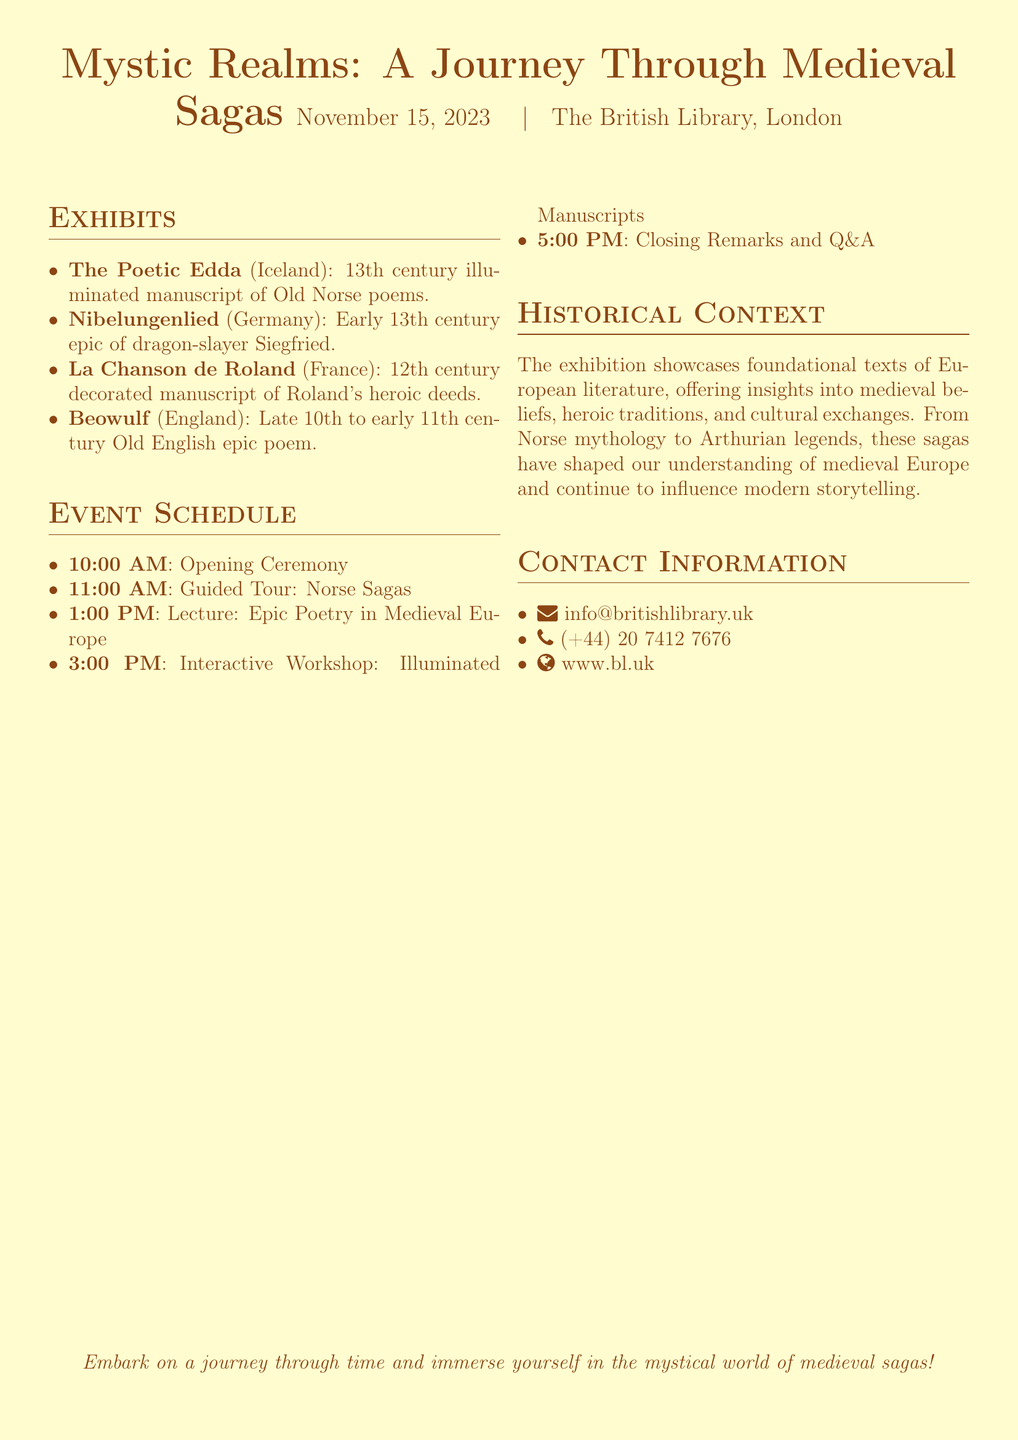What is the title of the exhibition? The title of the exhibition is prominently stated at the beginning of the document.
Answer: Mystic Realms: A Journey Through Medieval Sagas When does the exhibition take place? The date of the exhibition is mentioned near the title.
Answer: November 15, 2023 What is the first event on the schedule? The opening event is listed first in the event schedule section.
Answer: Opening Ceremony How many exhibits are mentioned in the document? The number of exhibits can be counted in the list provided under the exhibits section.
Answer: Four What is the historical context of the exhibition? The historical context outlines the significance of the texts being showcased.
Answer: Foundational texts of European literature Which manuscript is associated with dragon-slayer Siegfried? The document specifies the associated manuscript in the exhibits section.
Answer: Nibelungenlied What time is the lecture about epic poetry? The specific time for the lecture is indicated in the event schedule.
Answer: 1:00 PM What country is the Poetic Edda from? The document clearly states the country in the exhibit description.
Answer: Iceland What type of workshop is scheduled for the exhibition? The workshop type is specifically mentioned in the event schedule.
Answer: Interactive Workshop: Illuminated Manuscripts 